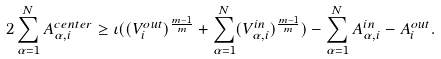Convert formula to latex. <formula><loc_0><loc_0><loc_500><loc_500>2 \sum _ { \alpha = 1 } ^ { N } A _ { \alpha , i } ^ { c e n t e r } \geq \iota ( ( V _ { i } ^ { o u t } ) ^ { \frac { m - 1 } { m } } + \sum _ { \alpha = 1 } ^ { N } ( V _ { \alpha , i } ^ { i n } ) ^ { \frac { m - 1 } { m } } ) - \sum _ { \alpha = 1 } ^ { N } A _ { \alpha , i } ^ { i n } - A _ { i } ^ { o u t } .</formula> 